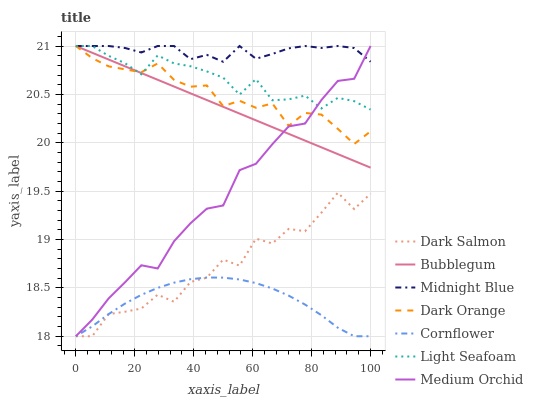Does Cornflower have the minimum area under the curve?
Answer yes or no. Yes. Does Midnight Blue have the maximum area under the curve?
Answer yes or no. Yes. Does Midnight Blue have the minimum area under the curve?
Answer yes or no. No. Does Cornflower have the maximum area under the curve?
Answer yes or no. No. Is Bubblegum the smoothest?
Answer yes or no. Yes. Is Dark Salmon the roughest?
Answer yes or no. Yes. Is Midnight Blue the smoothest?
Answer yes or no. No. Is Midnight Blue the roughest?
Answer yes or no. No. Does Midnight Blue have the lowest value?
Answer yes or no. No. Does Cornflower have the highest value?
Answer yes or no. No. Is Dark Salmon less than Midnight Blue?
Answer yes or no. Yes. Is Dark Orange greater than Cornflower?
Answer yes or no. Yes. Does Dark Salmon intersect Midnight Blue?
Answer yes or no. No. 